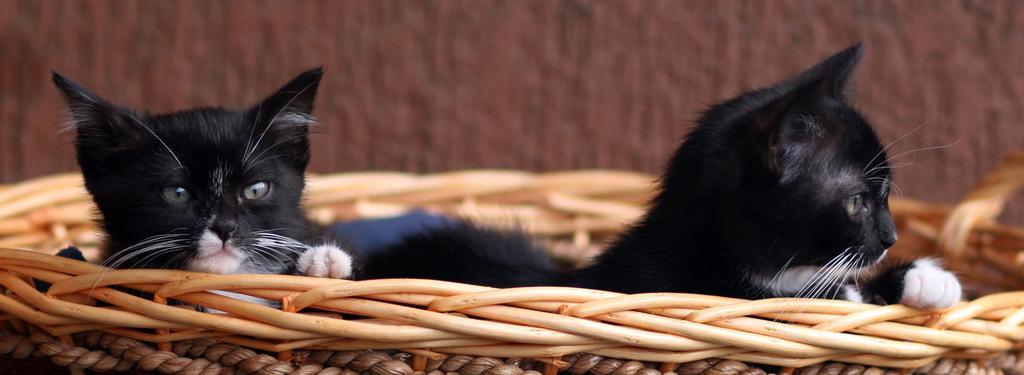Describe this image in one or two sentences. In this image I can see an animals which are in black and white color. These are in the wooden basket. I can see the brown background. 